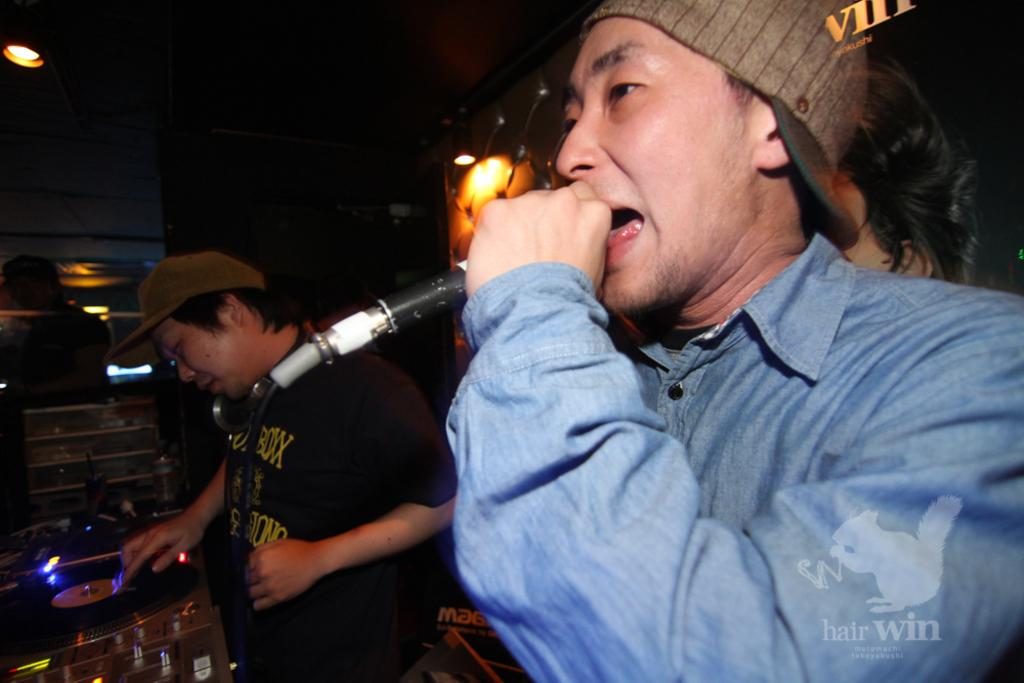How many people are in the image? There are two men in the image. What is one of the men doing in the image? One man is holding a microphone. What is the other man doing in the image? The other man is swiping a music tape. What type of fork is the man using to control the music tape? There is no fork present in the image, and the man is not using any tool to control the music tape; he is simply swiping it. 